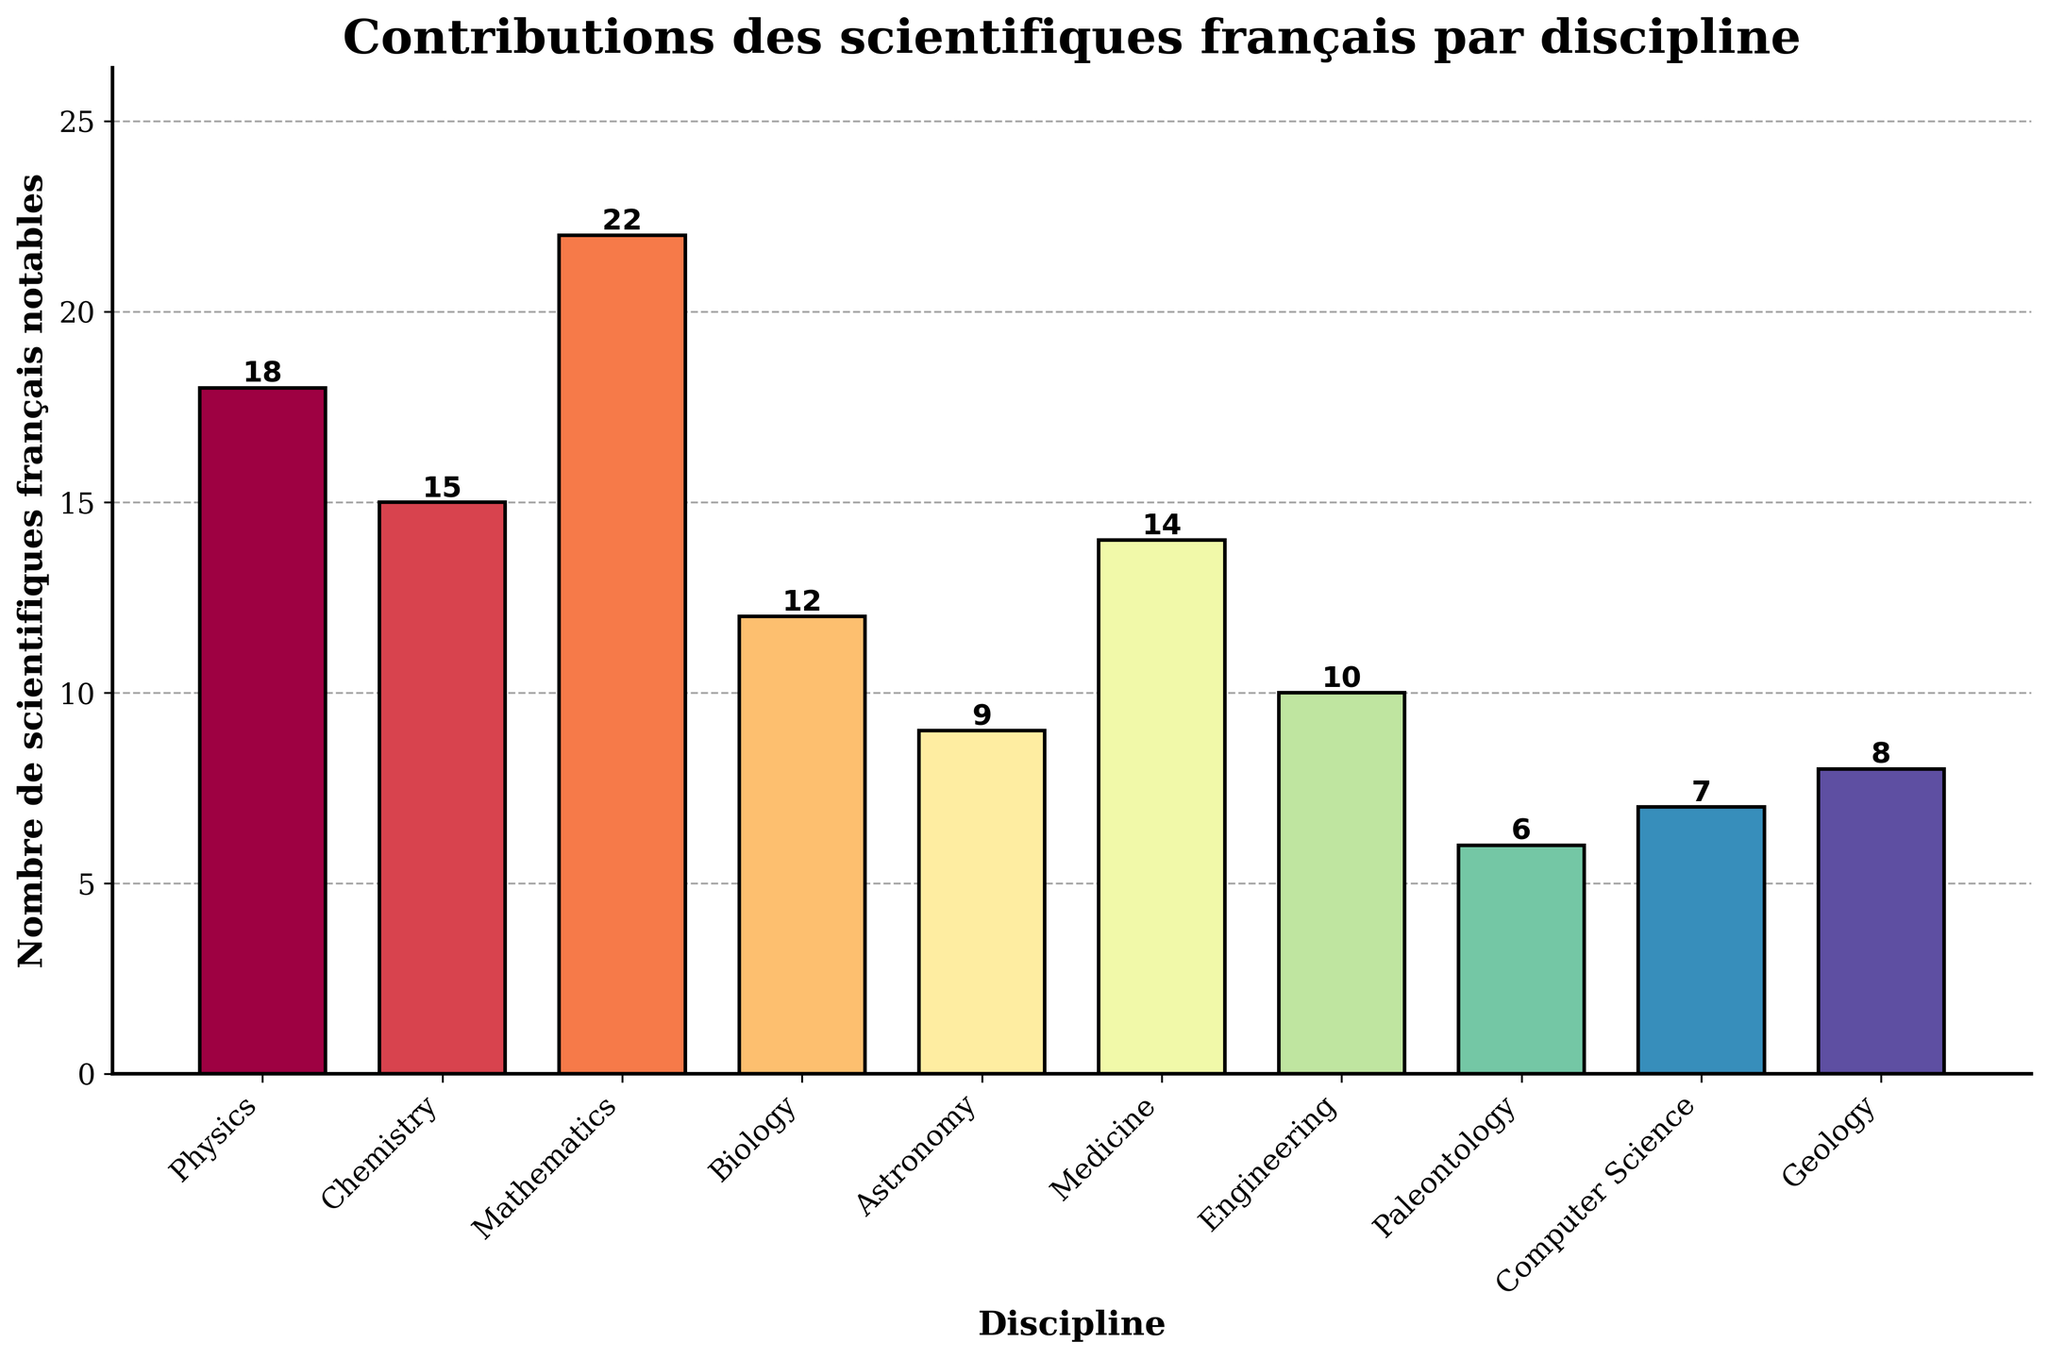What discipline has the highest number of notable French scientists? Look for the tallest bar in the chart. Mathematics has the tallest bar.
Answer: Mathematics What is the ratio of notable French scientists in Physics to those in Paleontology? Find the heights (number of scientists) for Physics and Paleontology. Physics has 18 scientists, Paleontology has 6. The ratio is 18:6, which simplifies to 3:1.
Answer: 3:1 How many more notable French scientists are there in Chemistry compared to Geology? Look at the heights of the bars for Chemistry and Geology. Chemistry has 15 scientists, Geology has 8. Subtract 8 from 15.
Answer: 7 Which disciplines have fewer than 10 notable French scientists? Identify bars that are shorter than the bar for 10 scientists. Paleontology (6), Computer Science (7), and Geology (8) meet this criterion.
Answer: Paleontology, Computer Science, Geology How many total notable French scientists contributed to Physics, Chemistry, and Biology combined? Add the number of scientists for Physics (18), Chemistry (15), and Biology (12). 18 + 15 + 12 = 45.
Answer: 45 Which discipline has the closest number of notable French scientists to Medicine? Look at the height of the bar for Medicine, which is 14. Find bars with heights close to 14. Engineering has 10, and Chemistry has 15. Chemistry is the closest.
Answer: Chemistry Are there more notable French scientists in Astronomy or in Computer Science and Geology combined? Compare the number of scientists in Astronomy (9) to the sum of Computer Science (7) and Geology (8). 7 + 8 = 15, which is greater than 9.
Answer: Computer Science and Geology combined Which disciplines have a higher number of notable French scientists than Astronomy but fewer than Mathematics? Astronomy has 9 scientists, and Mathematics has 22. Look for bars with heights between 9 and 22: Physics (18), Chemistry (15), Medicine (14), Engineering (10), and Biology (12).
Answer: Physics, Chemistry, Medicine, Engineering, Biology What’s the average number of notable French scientists across all disciplines? Sum the number of scientists for all disciplines (18+15+22+12+9+14+10+6+7+8 = 121). Divide by the number of disciplines (10). 121/10 = 12.1.
Answer: 12.1 Which discipline's bar is the least visually prominent in terms of height? Identify the shortest bar, which indicates the smallest number of noticeable scientists. Paleontology has the shortest bar with a height of 6.
Answer: Paleontology 